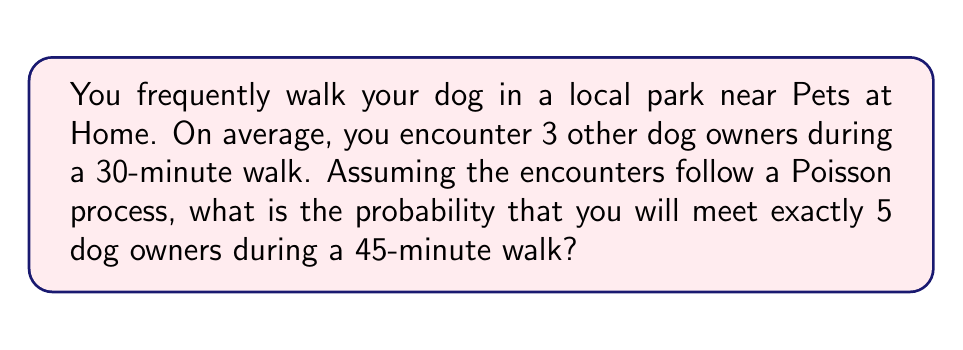Provide a solution to this math problem. Let's approach this step-by-step:

1) First, we need to determine the rate (λ) of encountering dog owners per minute:
   λ = 3 encounters / 30 minutes = 0.1 encounters/minute

2) For a 45-minute walk, the expected number of encounters (μ) is:
   μ = λ * 45 = 0.1 * 45 = 4.5 encounters

3) We want to find P(X = 5), where X is the number of encounters. For a Poisson process, this probability is given by:

   $$P(X = k) = \frac{e^{-μ} μ^k}{k!}$$

   Where:
   - e is Euler's number (≈ 2.71828)
   - μ is the expected number of occurrences
   - k is the number of occurrences we're interested in (5 in this case)

4) Substituting our values:

   $$P(X = 5) = \frac{e^{-4.5} 4.5^5}{5!}$$

5) Calculating this:
   
   $$P(X = 5) = \frac{2.71828^{-4.5} * 4.5^5}{5 * 4 * 3 * 2 * 1} \approx 0.1708$$

6) Therefore, the probability of encountering exactly 5 dog owners during a 45-minute walk is approximately 0.1708 or 17.08%.
Answer: 0.1708 